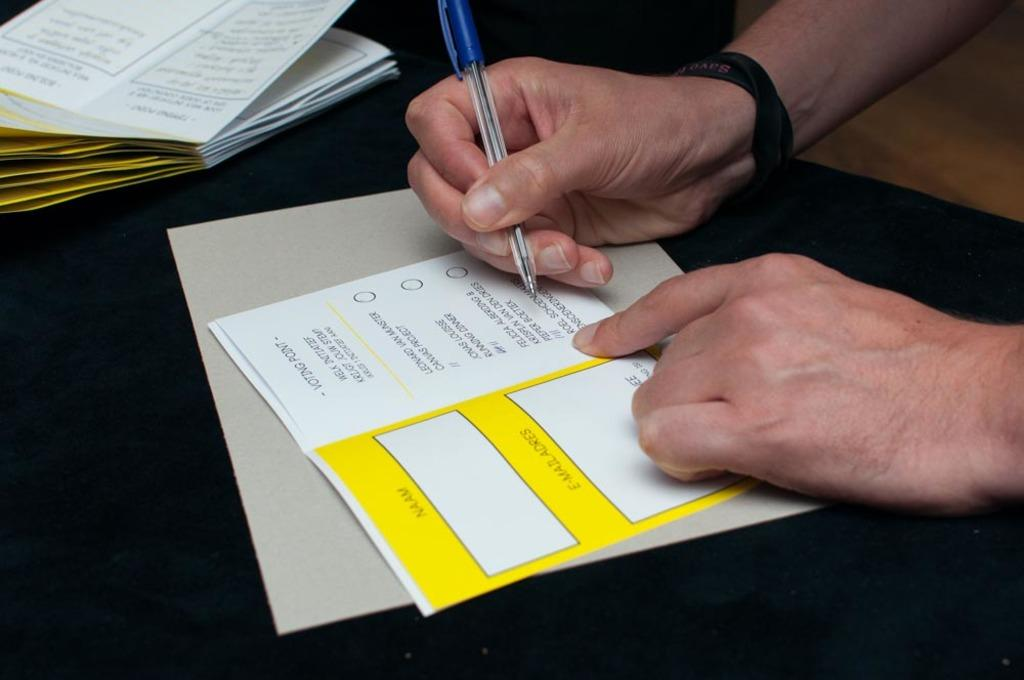Provide a one-sentence caption for the provided image. A person is filling out a voting form with a pen. 